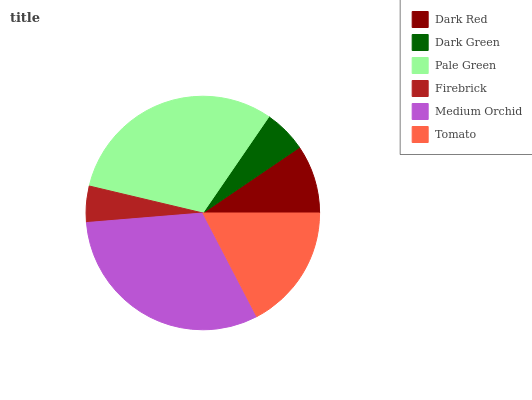Is Firebrick the minimum?
Answer yes or no. Yes. Is Medium Orchid the maximum?
Answer yes or no. Yes. Is Dark Green the minimum?
Answer yes or no. No. Is Dark Green the maximum?
Answer yes or no. No. Is Dark Red greater than Dark Green?
Answer yes or no. Yes. Is Dark Green less than Dark Red?
Answer yes or no. Yes. Is Dark Green greater than Dark Red?
Answer yes or no. No. Is Dark Red less than Dark Green?
Answer yes or no. No. Is Tomato the high median?
Answer yes or no. Yes. Is Dark Red the low median?
Answer yes or no. Yes. Is Dark Red the high median?
Answer yes or no. No. Is Dark Green the low median?
Answer yes or no. No. 